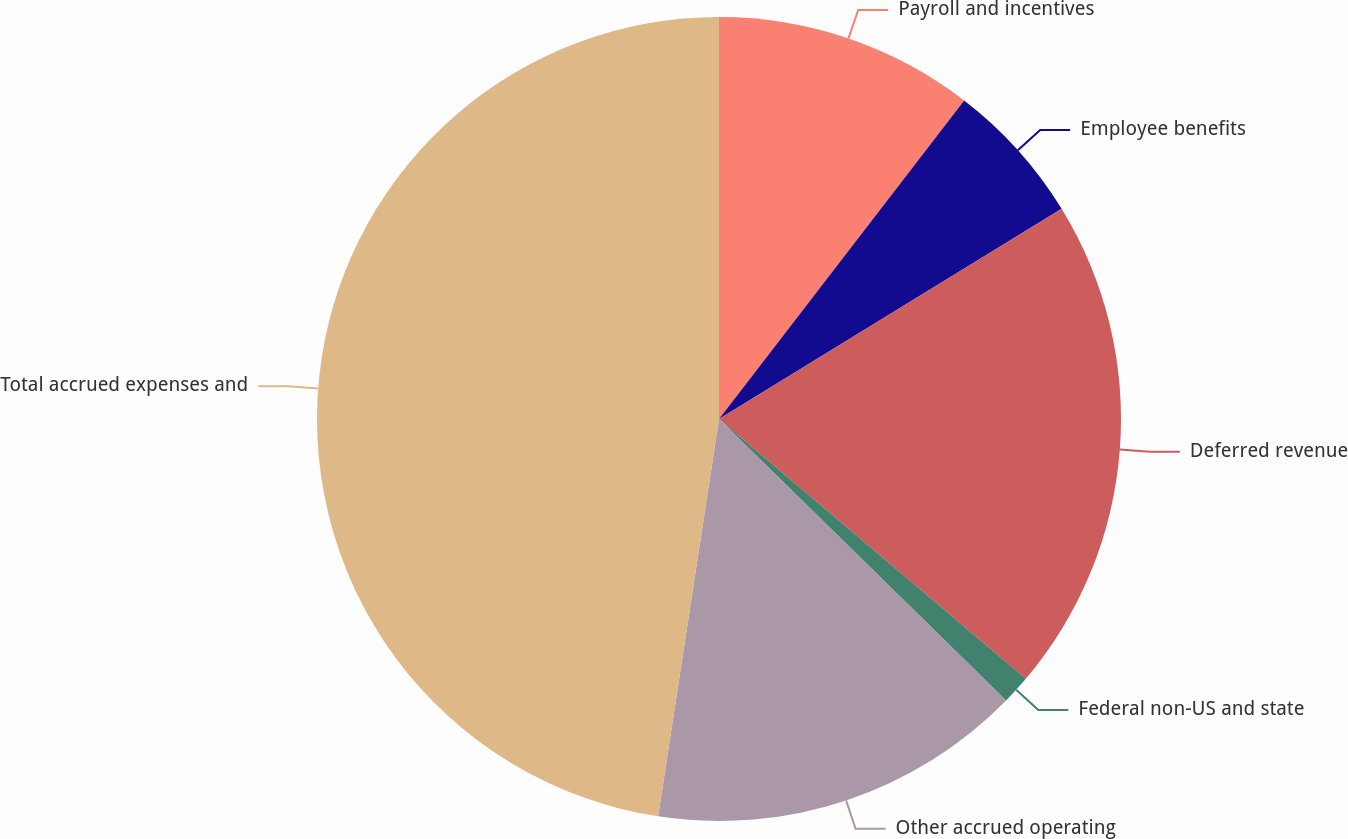<chart> <loc_0><loc_0><loc_500><loc_500><pie_chart><fcel>Payroll and incentives<fcel>Employee benefits<fcel>Deferred revenue<fcel>Federal non-US and state<fcel>Other accrued operating<fcel>Total accrued expenses and<nl><fcel>10.44%<fcel>5.8%<fcel>19.94%<fcel>1.16%<fcel>15.08%<fcel>47.58%<nl></chart> 